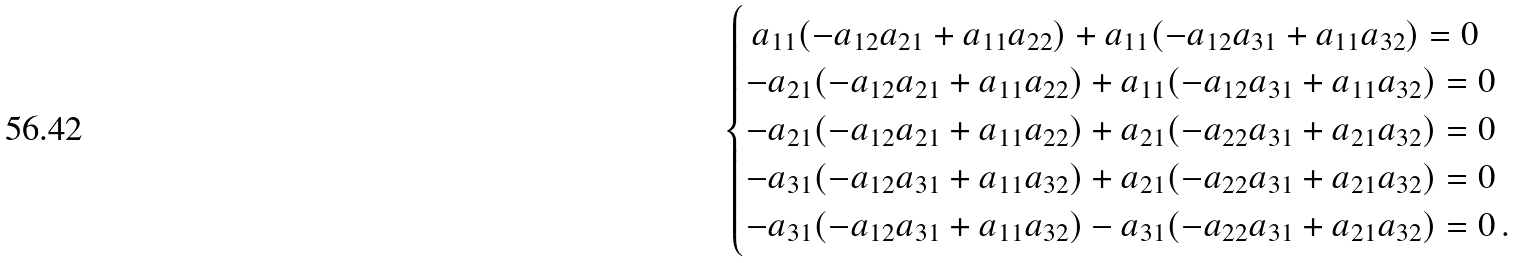Convert formula to latex. <formula><loc_0><loc_0><loc_500><loc_500>\begin{cases} \, a _ { 1 1 } ( - a _ { 1 2 } a _ { 2 1 } + a _ { 1 1 } a _ { 2 2 } ) + a _ { 1 1 } ( - a _ { 1 2 } a _ { 3 1 } + a _ { 1 1 } a _ { 3 2 } ) = 0 \\ - a _ { 2 1 } ( - a _ { 1 2 } a _ { 2 1 } + a _ { 1 1 } a _ { 2 2 } ) + a _ { 1 1 } ( - a _ { 1 2 } a _ { 3 1 } + a _ { 1 1 } a _ { 3 2 } ) = 0 \\ - a _ { 2 1 } ( - a _ { 1 2 } a _ { 2 1 } + a _ { 1 1 } a _ { 2 2 } ) + a _ { 2 1 } ( - a _ { 2 2 } a _ { 3 1 } + a _ { 2 1 } a _ { 3 2 } ) = 0 \\ - a _ { 3 1 } ( - a _ { 1 2 } a _ { 3 1 } + a _ { 1 1 } a _ { 3 2 } ) + a _ { 2 1 } ( - a _ { 2 2 } a _ { 3 1 } + a _ { 2 1 } a _ { 3 2 } ) = 0 \\ - a _ { 3 1 } ( - a _ { 1 2 } a _ { 3 1 } + a _ { 1 1 } a _ { 3 2 } ) - a _ { 3 1 } ( - a _ { 2 2 } a _ { 3 1 } + a _ { 2 1 } a _ { 3 2 } ) = 0 \, . \end{cases}</formula> 